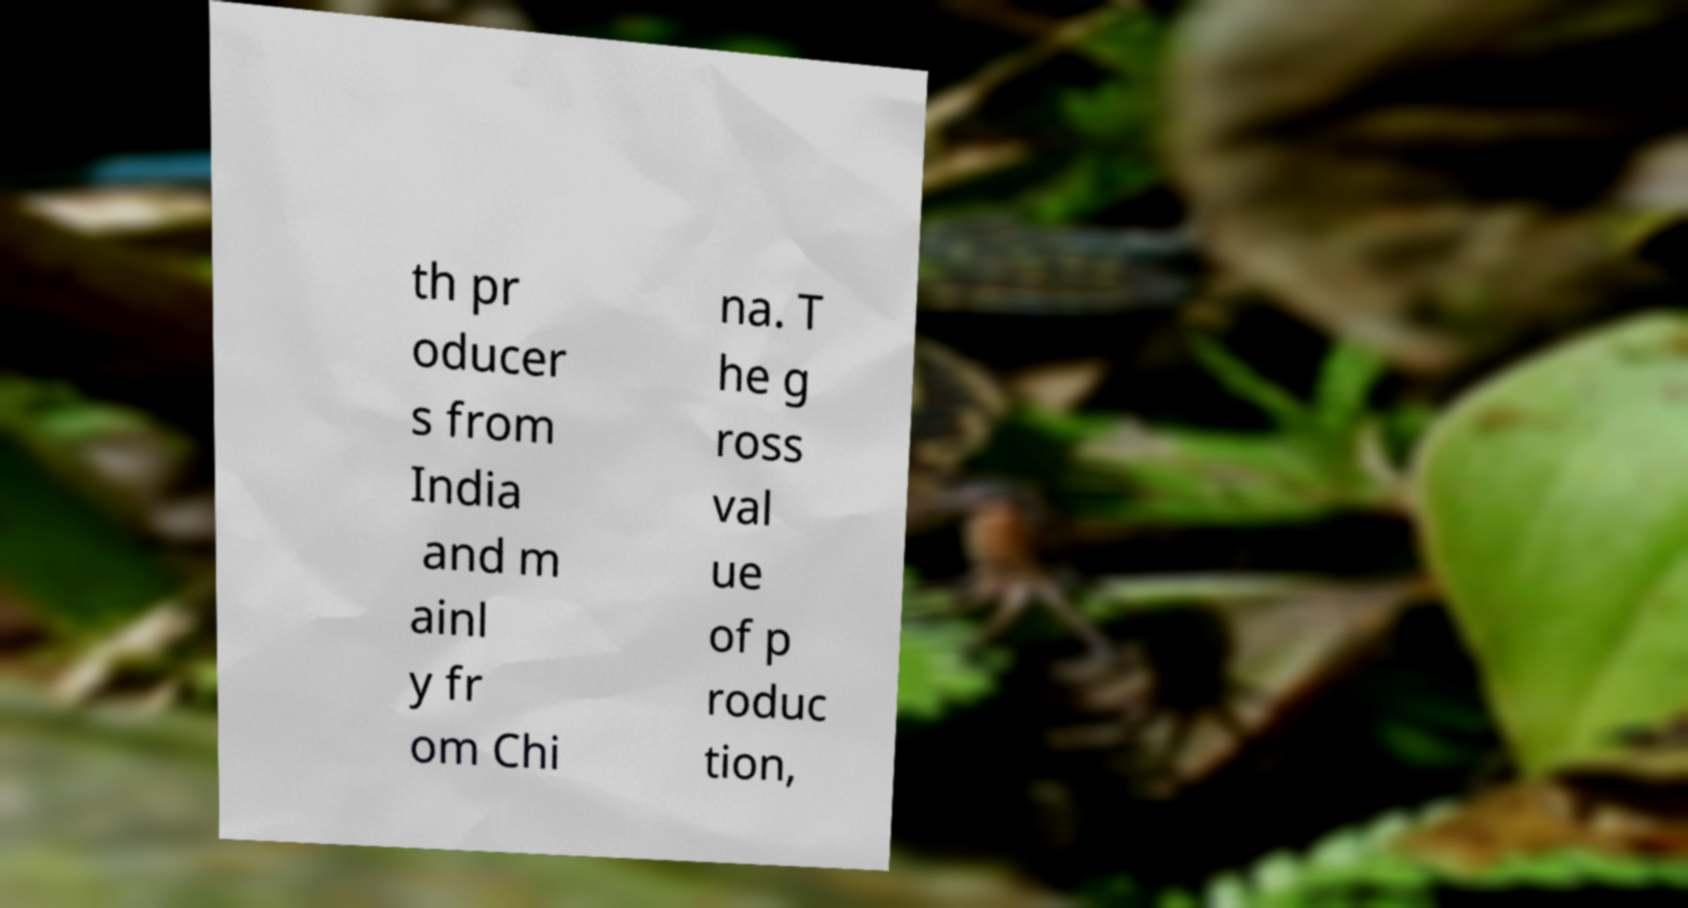Could you extract and type out the text from this image? th pr oducer s from India and m ainl y fr om Chi na. T he g ross val ue of p roduc tion, 